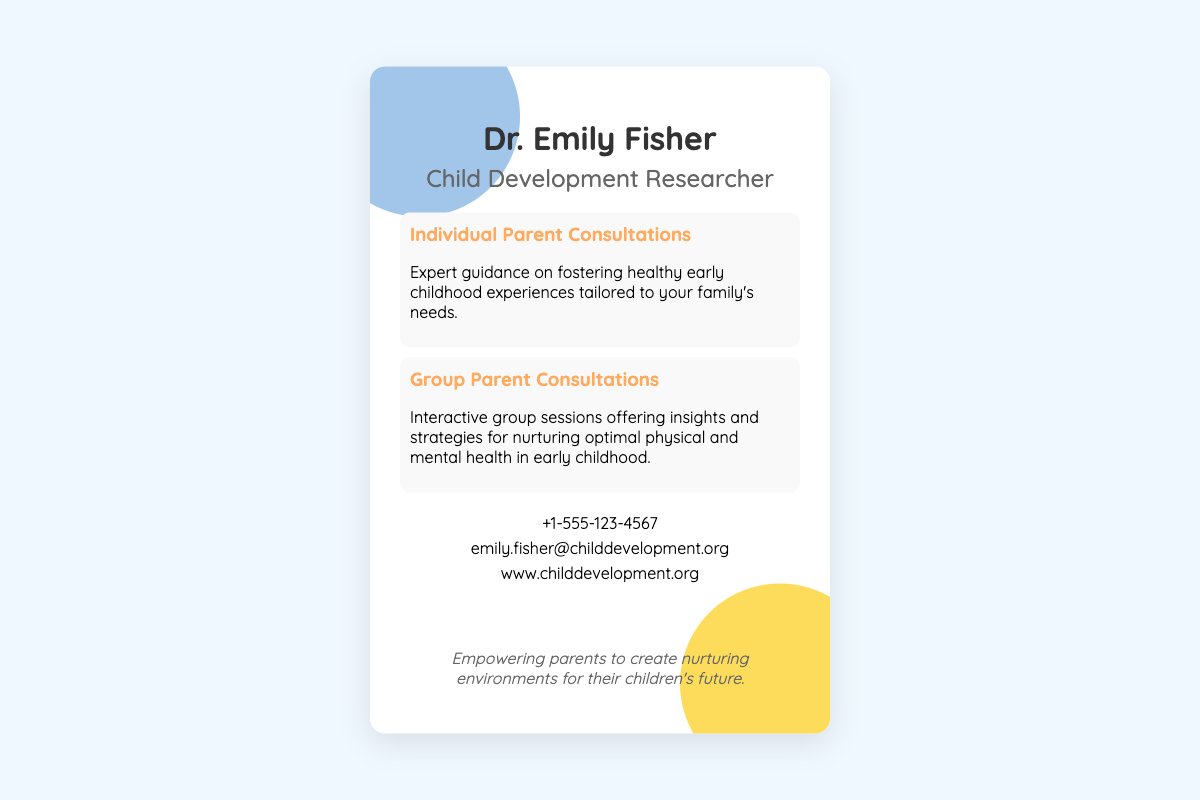what is the name of the researcher? The document includes the name "Dr. Emily Fisher" as the child development researcher.
Answer: Dr. Emily Fisher how many services are mentioned? There are two services listed in the document: Individual Parent Consultations and Group Parent Consultations.
Answer: Two what is the phone number provided? The document lists the contact phone number as "+1-555-123-4567".
Answer: +1-555-123-4567 what is the purpose of individual parent consultations? The individual consultations offer expert guidance on fostering healthy early childhood experiences tailored to families' needs.
Answer: Expert guidance what social media platform does Dr. Emily Fisher use? The document links to Facebook, Twitter, and LinkedIn as social media platforms used by Dr. Emily Fisher.
Answer: Facebook, Twitter, LinkedIn what color palette is used in the design? The document describes the design as using a soothing color palette including shades of blue and yellow.
Answer: Soothing color palette what type of interactions do group consultations involve? Group Parent Consultations provide interactive sessions for insights and strategies.
Answer: Interactive group sessions what is the primary message conveyed on the card? The friendly message at the bottom emphasizes empowering parents to create nurturing environments for their children's future.
Answer: Empowering parents 